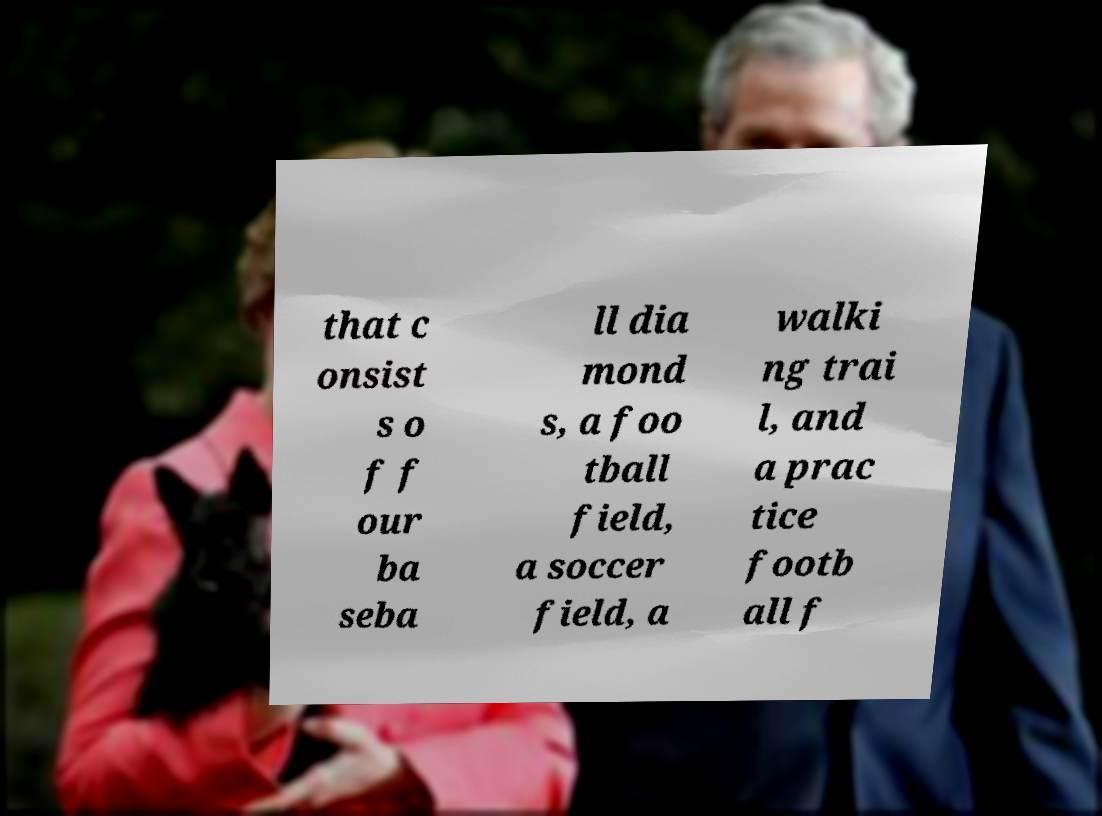I need the written content from this picture converted into text. Can you do that? that c onsist s o f f our ba seba ll dia mond s, a foo tball field, a soccer field, a walki ng trai l, and a prac tice footb all f 